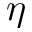Convert formula to latex. <formula><loc_0><loc_0><loc_500><loc_500>\eta</formula> 